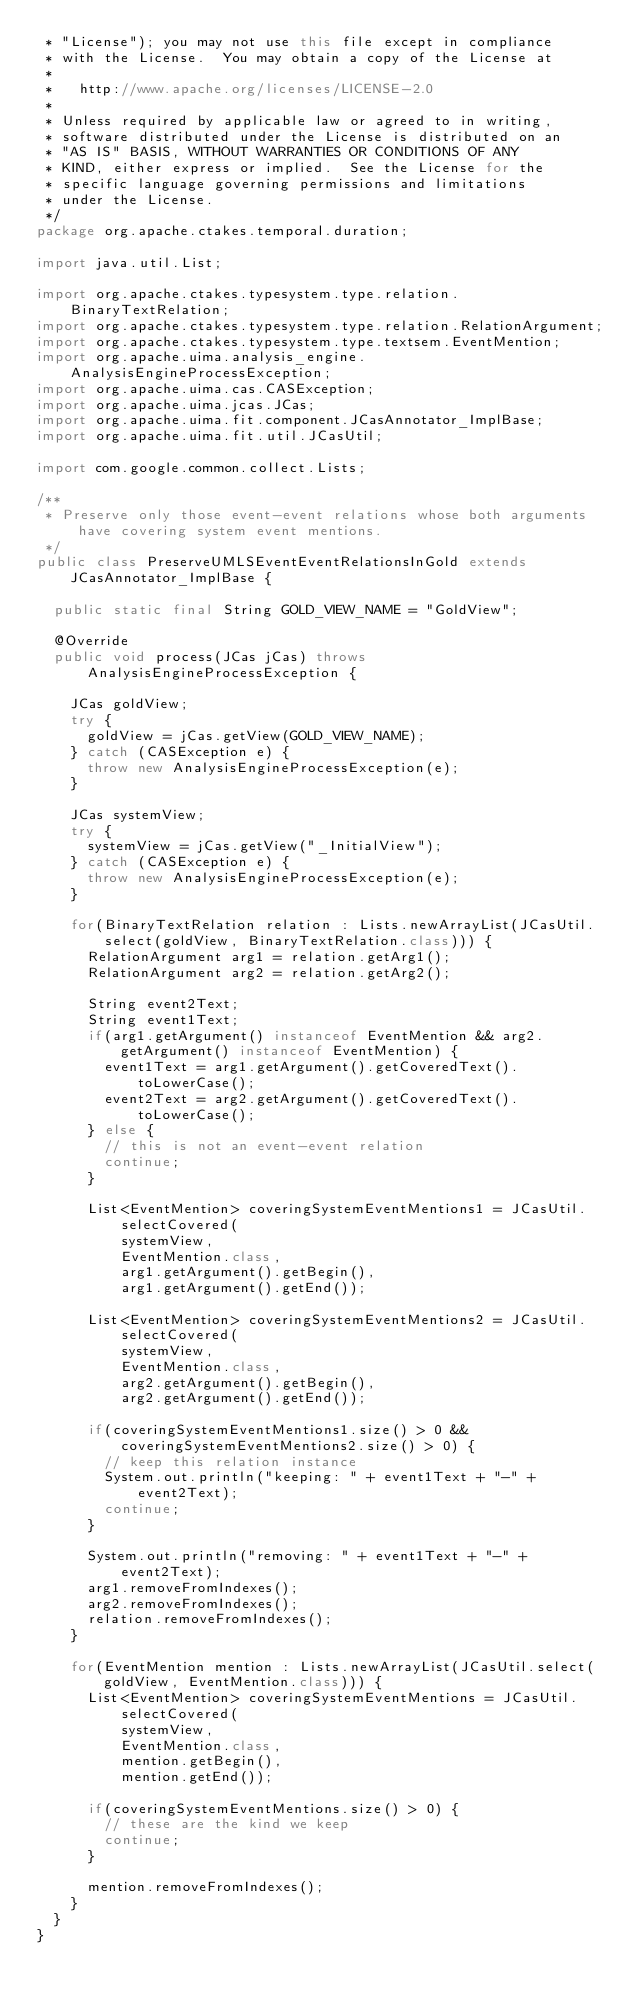<code> <loc_0><loc_0><loc_500><loc_500><_Java_> * "License"); you may not use this file except in compliance
 * with the License.  You may obtain a copy of the License at
 *
 *   http://www.apache.org/licenses/LICENSE-2.0
 *
 * Unless required by applicable law or agreed to in writing,
 * software distributed under the License is distributed on an
 * "AS IS" BASIS, WITHOUT WARRANTIES OR CONDITIONS OF ANY
 * KIND, either express or implied.  See the License for the
 * specific language governing permissions and limitations
 * under the License.
 */
package org.apache.ctakes.temporal.duration;

import java.util.List;

import org.apache.ctakes.typesystem.type.relation.BinaryTextRelation;
import org.apache.ctakes.typesystem.type.relation.RelationArgument;
import org.apache.ctakes.typesystem.type.textsem.EventMention;
import org.apache.uima.analysis_engine.AnalysisEngineProcessException;
import org.apache.uima.cas.CASException;
import org.apache.uima.jcas.JCas;
import org.apache.uima.fit.component.JCasAnnotator_ImplBase;
import org.apache.uima.fit.util.JCasUtil;

import com.google.common.collect.Lists;

/**
 * Preserve only those event-event relations whose both arguments have covering system event mentions.
 */
public class PreserveUMLSEventEventRelationsInGold extends JCasAnnotator_ImplBase {                                               
  
  public static final String GOLD_VIEW_NAME = "GoldView";

  @Override                                                                                                                  
  public void process(JCas jCas) throws AnalysisEngineProcessException {                                                     
    
    JCas goldView;                                                                                                           
    try {                                                                                                                    
      goldView = jCas.getView(GOLD_VIEW_NAME);                                                                               
    } catch (CASException e) {                                                                                               
      throw new AnalysisEngineProcessException(e);                                                                           
    }                                                                                                                                                                                                                                         

    JCas systemView;
    try {
      systemView = jCas.getView("_InitialView");
    } catch (CASException e) {
      throw new AnalysisEngineProcessException(e);
    }
    
    for(BinaryTextRelation relation : Lists.newArrayList(JCasUtil.select(goldView, BinaryTextRelation.class))) {            
      RelationArgument arg1 = relation.getArg1();                                                                             
      RelationArgument arg2 = relation.getArg2(); 

      String event2Text;
      String event1Text;
      if(arg1.getArgument() instanceof EventMention && arg2.getArgument() instanceof EventMention) {
        event1Text = arg1.getArgument().getCoveredText().toLowerCase();
        event2Text = arg2.getArgument().getCoveredText().toLowerCase();
      } else {
        // this is not an event-event relation
        continue;
      }
      
      List<EventMention> coveringSystemEventMentions1 = JCasUtil.selectCovered(
          systemView, 
          EventMention.class, 
          arg1.getArgument().getBegin(), 
          arg1.getArgument().getEnd());

      List<EventMention> coveringSystemEventMentions2 = JCasUtil.selectCovered(
          systemView, 
          EventMention.class, 
          arg2.getArgument().getBegin(), 
          arg2.getArgument().getEnd());
      
      if(coveringSystemEventMentions1.size() > 0 && coveringSystemEventMentions2.size() > 0) {
        // keep this relation instance
        System.out.println("keeping: " + event1Text + "-" + event2Text);
        continue;
      }
      
      System.out.println("removing: " + event1Text + "-" + event2Text);
      arg1.removeFromIndexes();                                                                                            
      arg2.removeFromIndexes();                                                                                            
      relation.removeFromIndexes();
    }
    
    for(EventMention mention : Lists.newArrayList(JCasUtil.select(goldView, EventMention.class))) {
      List<EventMention> coveringSystemEventMentions = JCasUtil.selectCovered(
          systemView, 
          EventMention.class, 
          mention.getBegin(), 
          mention.getEnd());
      
      if(coveringSystemEventMentions.size() > 0) {
        // these are the kind we keep
        continue;
      } 
      
      mention.removeFromIndexes();
    }
  }                                                                                                                          
}                                                                                                                            </code> 